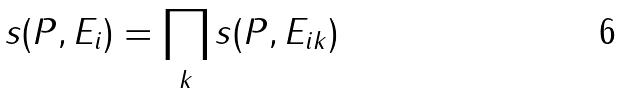<formula> <loc_0><loc_0><loc_500><loc_500>s ( P , E _ { i } ) = \prod _ { k } s ( P , E _ { i k } )</formula> 